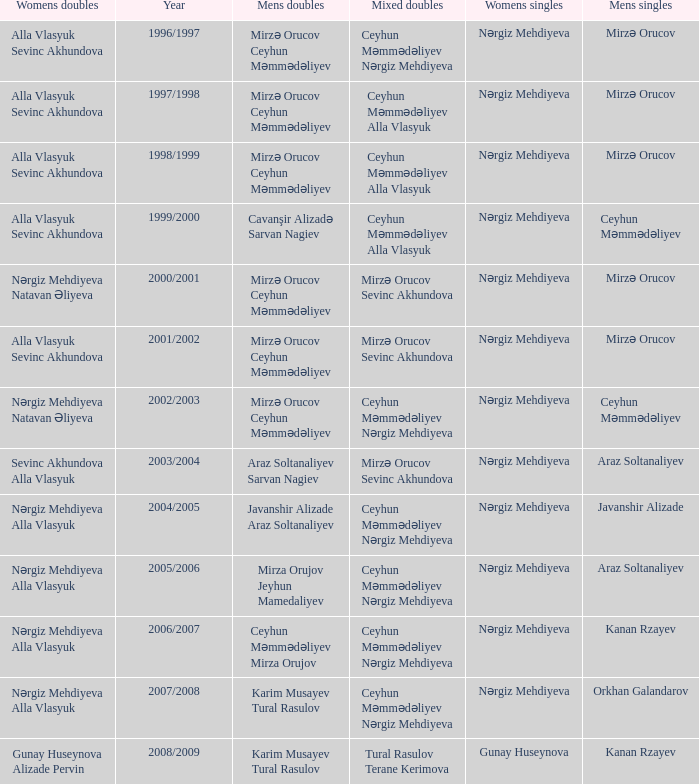What are all values for Womens Doubles in the year 2000/2001? Nərgiz Mehdiyeva Natavan Əliyeva. 